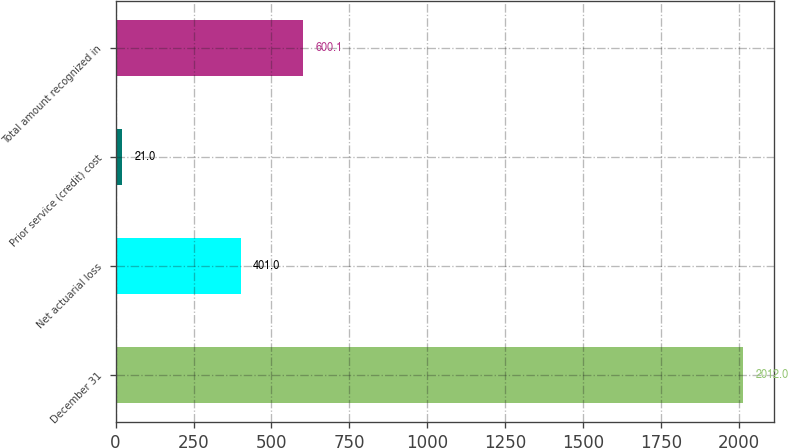<chart> <loc_0><loc_0><loc_500><loc_500><bar_chart><fcel>December 31<fcel>Net actuarial loss<fcel>Prior service (credit) cost<fcel>Total amount recognized in<nl><fcel>2012<fcel>401<fcel>21<fcel>600.1<nl></chart> 